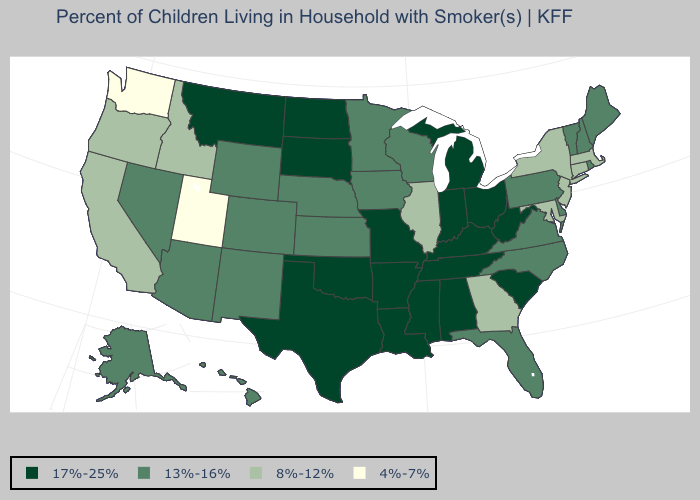What is the lowest value in the USA?
Concise answer only. 4%-7%. Does Pennsylvania have a higher value than Massachusetts?
Give a very brief answer. Yes. Does the first symbol in the legend represent the smallest category?
Give a very brief answer. No. Which states have the lowest value in the MidWest?
Answer briefly. Illinois. Which states have the highest value in the USA?
Give a very brief answer. Alabama, Arkansas, Indiana, Kentucky, Louisiana, Michigan, Mississippi, Missouri, Montana, North Dakota, Ohio, Oklahoma, South Carolina, South Dakota, Tennessee, Texas, West Virginia. Does Virginia have the lowest value in the South?
Concise answer only. No. Which states have the lowest value in the USA?
Keep it brief. Utah, Washington. What is the highest value in states that border Delaware?
Quick response, please. 13%-16%. Name the states that have a value in the range 4%-7%?
Concise answer only. Utah, Washington. What is the lowest value in states that border Pennsylvania?
Answer briefly. 8%-12%. Does Pennsylvania have a lower value than California?
Keep it brief. No. Name the states that have a value in the range 13%-16%?
Write a very short answer. Alaska, Arizona, Colorado, Delaware, Florida, Hawaii, Iowa, Kansas, Maine, Minnesota, Nebraska, Nevada, New Hampshire, New Mexico, North Carolina, Pennsylvania, Rhode Island, Vermont, Virginia, Wisconsin, Wyoming. What is the lowest value in states that border Arizona?
Give a very brief answer. 4%-7%. Which states have the highest value in the USA?
Quick response, please. Alabama, Arkansas, Indiana, Kentucky, Louisiana, Michigan, Mississippi, Missouri, Montana, North Dakota, Ohio, Oklahoma, South Carolina, South Dakota, Tennessee, Texas, West Virginia. Does Vermont have a lower value than Delaware?
Keep it brief. No. 